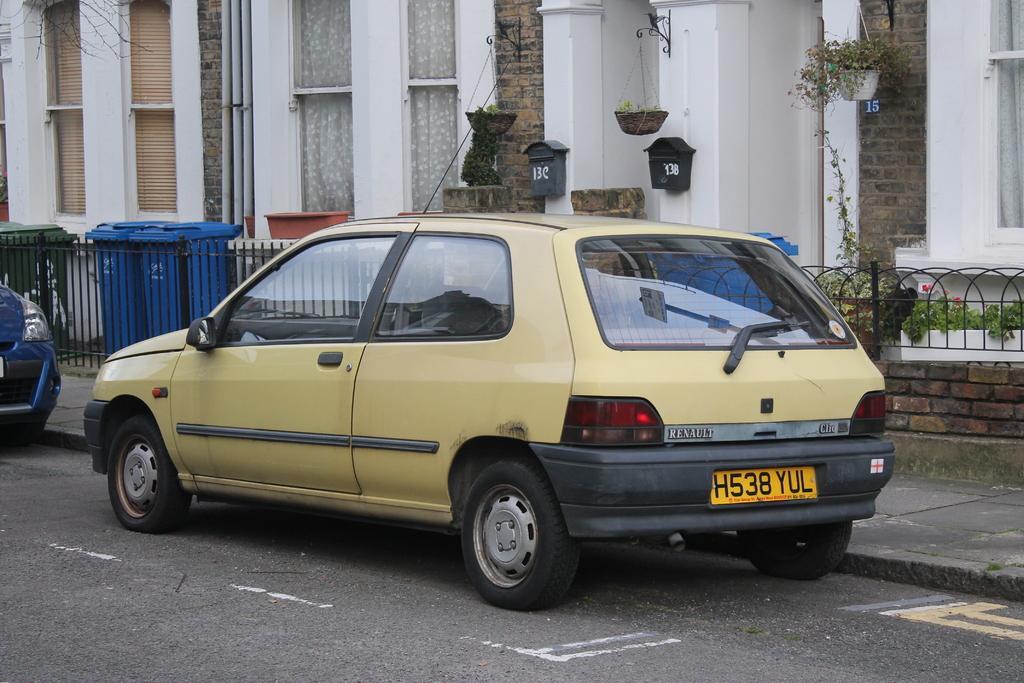Could you give a brief overview of what you see in this image? In this image I can see few vehicles on the road. I can see few buildings, windows, flowerpots, dustbins, plants, fencing and few post boxes to the wall. 